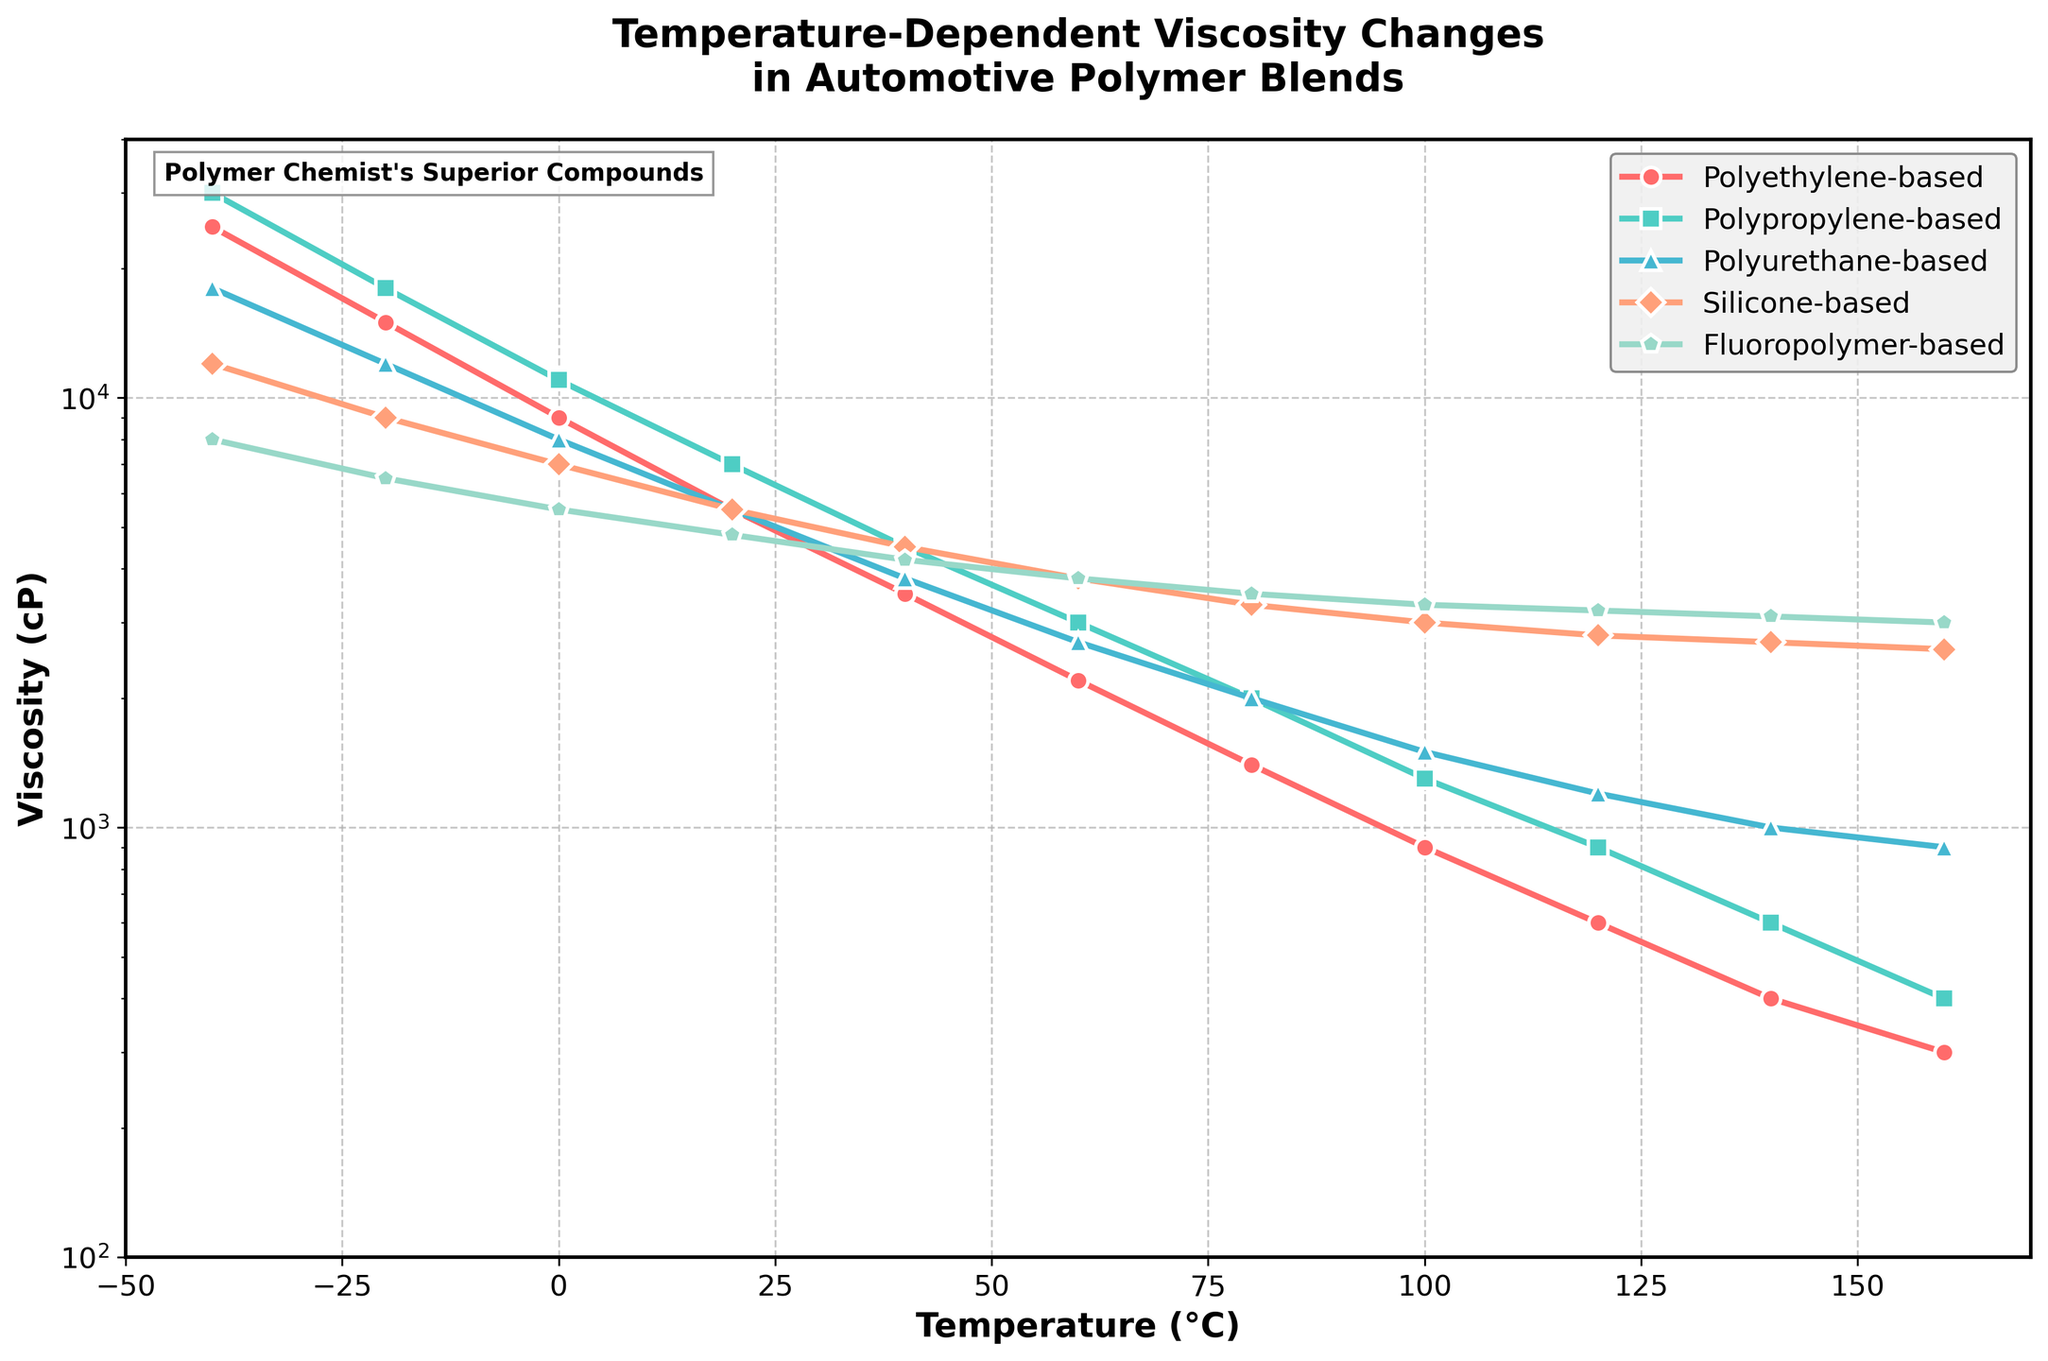What is the viscosity of the Fluoropolymer-based blend at 20°C? To find the viscosity at 20°C for the Fluoropolymer-based formulation, locate 20°C on the x-axis and follow vertically to the Fluoropolymer-based line (represented in the legend). The corresponding point on the y-axis gives the viscosity value.
Answer: 4800 cP Which blend has the highest viscosity at -40°C? Compare the viscosity values of all blends at -40°C by locating -40°C on the x-axis and comparing the heights of the points for each line. The highest point indicates the greatest viscosity. Polypropylene-based is the uppermost point.
Answer: Polypropylene-based How does the viscosity of the Polyethylene-based blend change from -40°C to 20°C? Analyze the Polyethylene-based line from -40°C to 20°C. At -40°C, viscosity is 25000 cP, and at 20°C, it is 5500 cP. Find the difference: 25000 - 5500. Then, observe the trend from high to lower viscosity.
Answer: It decreases by 19500 cP Which blend experiences the smallest change in viscosity between 60°C and 120°C? Compare the viscosities of all blends at 60°C and 120°C. Calculate differences using the points on the y-axis. Choose the blend with the smallest difference.
Answer: Polypropylene-based (3000 cP to 900 cP = 2100 cP change) At what temperature does the Silicone-based blend's viscosity first drop below 5000 cP? Track the Silicone-based line from the lowest temperature until it falls below the 5000 cP mark on the y-axis. This occurs around 40°C.
Answer: 40°C How much greater is the viscosity of the Polyurethane-based blend than the Silicone-based blend at 160°C? Find the viscosities at 160°C for both blends: Polyurethane-based (900 cP) and Silicone-based (2600 cP). Calculate the difference: 2600 - 900.
Answer: 1700 cP Which formulation maintains the highest viscosity at 100°C? Compare the positions of all blend lines at 100°C. The higher position on the y-axis indicates a higher viscosity. Fluoropolymer-based is the highest.
Answer: Fluoropolymer-based What is the average viscosity of the Fluoropolymer-based blend between -40°C and 40°C? Extract the viscosities at -40, -20, 0, 20, and 40°C: (8000, 6500, 5500, 4800, 4200). Add these together and divide by the number of points (5). Average = (8000 + 6500 + 5500 + 4800 + 4200) / 5 = 5800.
Answer: 5800 cP How does the viscosity of the Polyurethane-based blend at 60°C compare to the Fluoropolymer-based blend at the same temperature? Locate both blends' viscosities at 60°C on the y-axis. Polyurethane-based is 2700 cP, and Fluoropolymer-based is 3800 cP. Polyurethane-based is less viscous.
Answer: Polyurethane-based is 1100 cP less Which blend shows the steepest decrease in viscosity from 20°C to 80°C? Observe the rate of change from 20°C to 80°C for each blend. Calculate the differences: Polyethylene-based decreases by 4100 cP, Polypropylene-based decreases by 5000 cP, Polyurethane-based decreases by 3500 cP, Silicone-based decreases by 2200 cP, and Fluoropolymer-based decreases by 1300 cP. The blend with the greatest decrease is the one with the highest difference.
Answer: Polypropylene-based 